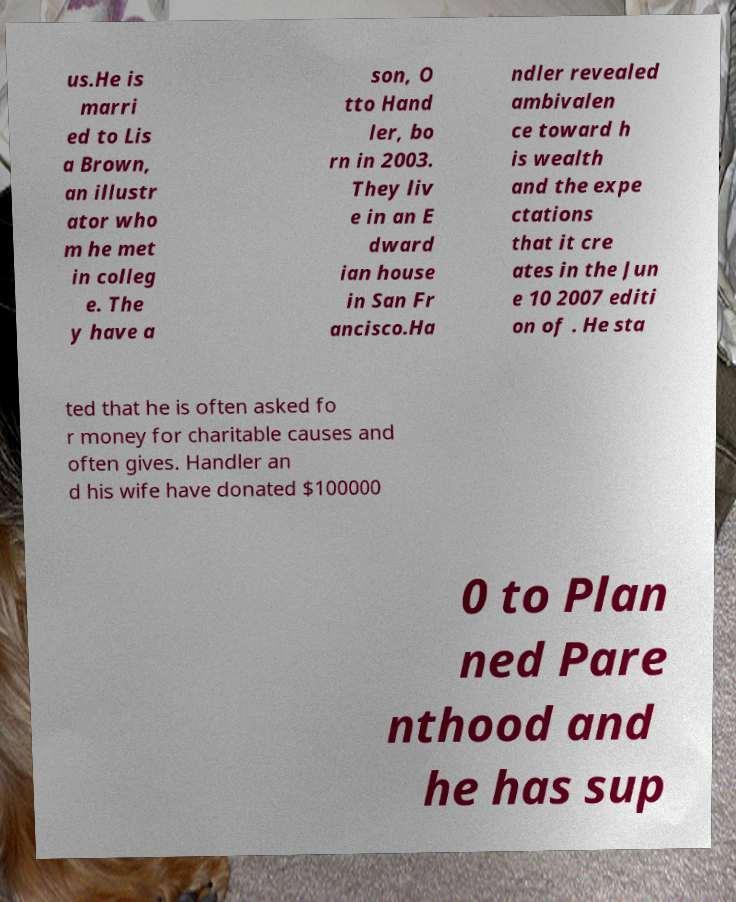For documentation purposes, I need the text within this image transcribed. Could you provide that? us.He is marri ed to Lis a Brown, an illustr ator who m he met in colleg e. The y have a son, O tto Hand ler, bo rn in 2003. They liv e in an E dward ian house in San Fr ancisco.Ha ndler revealed ambivalen ce toward h is wealth and the expe ctations that it cre ates in the Jun e 10 2007 editi on of . He sta ted that he is often asked fo r money for charitable causes and often gives. Handler an d his wife have donated $100000 0 to Plan ned Pare nthood and he has sup 